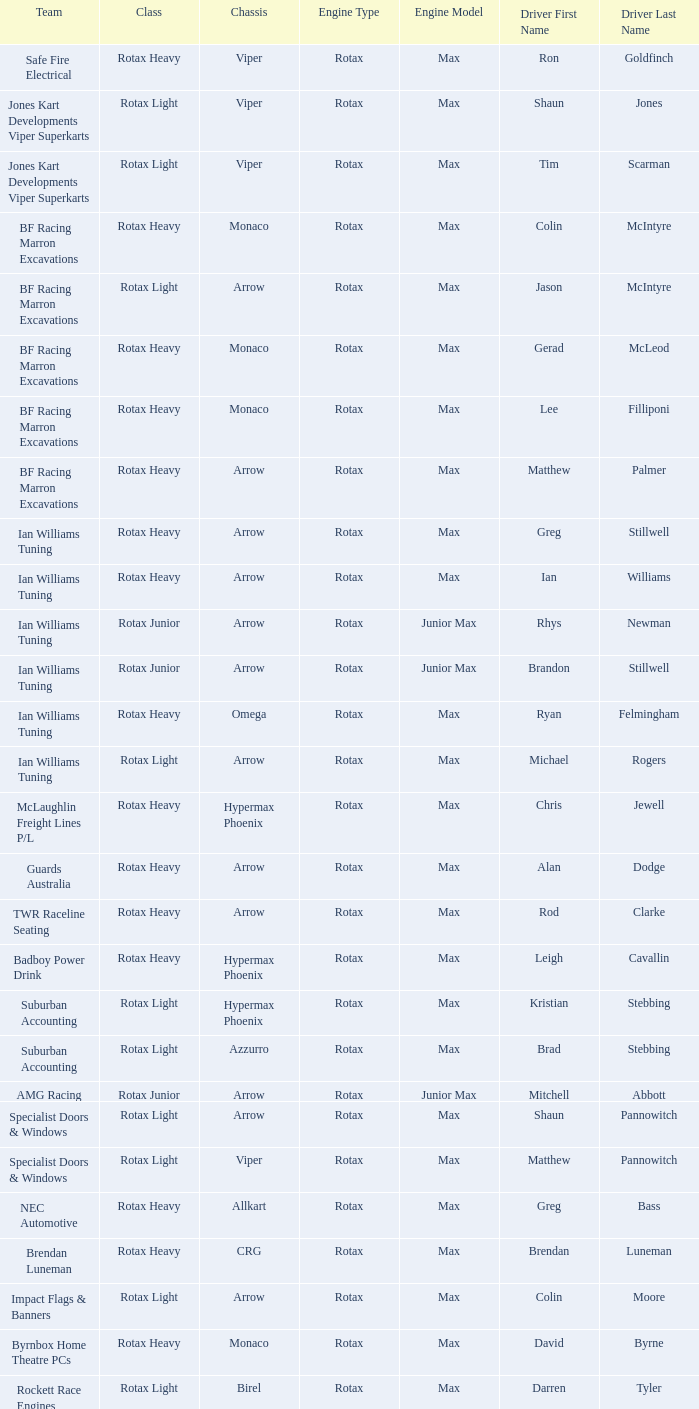Which team does Colin Moore drive for? Impact Flags & Banners. 